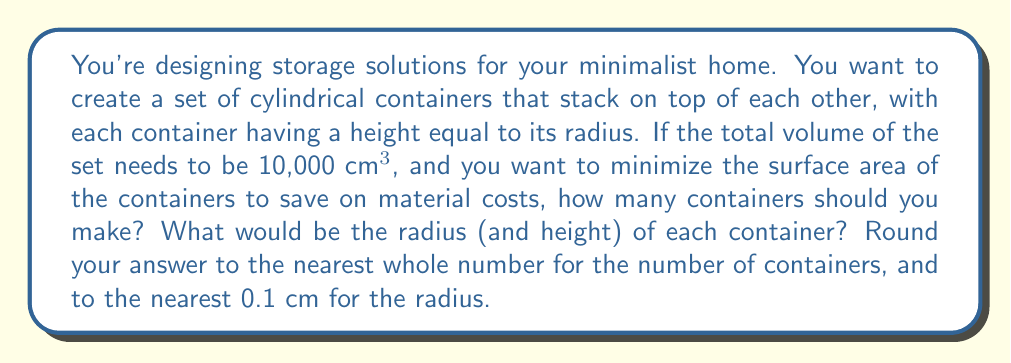Give your solution to this math problem. Let's approach this step-by-step:

1) Let's say we have $n$ containers, each with radius $r$ and height $h$. We know that $h = r$ for each container.

2) The volume of each cylinder is:
   $$V = \pi r^2 h = \pi r^3$$

3) The total volume for $n$ containers is:
   $$10000 = n \pi r^3$$

4) The surface area of each cylinder (excluding the top of the topmost cylinder) is:
   $$SA = 2\pi r^2 + 2\pi rh = 2\pi r^2 + 2\pi r^2 = 4\pi r^2$$

5) The total surface area for $n$ containers is:
   $$SA_{total} = n(4\pi r^2) + \pi r^2$$ 
   (We add $\pi r^2$ for the top of the topmost cylinder)

6) We can express $r$ in terms of $n$ using the volume equation:
   $$r = \sqrt[3]{\frac{10000}{n\pi}}$$

7) Substituting this into the surface area equation:
   $$SA_{total} = n(4\pi (\frac{10000}{n\pi})^{2/3}) + \pi (\frac{10000}{n\pi})^{2/3}$$

8) Simplifying:
   $$SA_{total} = 4n^{1/3}(10000\pi)^{2/3} + n^{-2/3}(10000\pi)^{2/3}$$

9) To find the minimum, we differentiate with respect to $n$ and set to zero:
   $$\frac{d(SA_{total})}{dn} = \frac{4}{3}n^{-2/3}(10000\pi)^{2/3} - \frac{2}{3}n^{-5/3}(10000\pi)^{2/3} = 0$$

10) Solving this equation:
    $$4n = 2$$
    $$n = \frac{1}{2}$$

11) The second derivative is positive, confirming this is a minimum. However, we need a whole number of containers, so we check $n = 1$ and $n = 2$:

    For $n = 1$: $r = 13.4$ cm, $SA_{total} = 1131.0$ cm²
    For $n = 2$: $r = 10.6$ cm, $SA_{total} = 1124.9$ cm²

Therefore, 2 containers minimize the surface area.

12) With $n = 2$, we can calculate the exact radius:
    $$r = \sqrt[3]{\frac{10000}{2\pi}} \approx 10.6$$ cm
Answer: Number of containers: 2
Radius (and height) of each container: 10.6 cm 